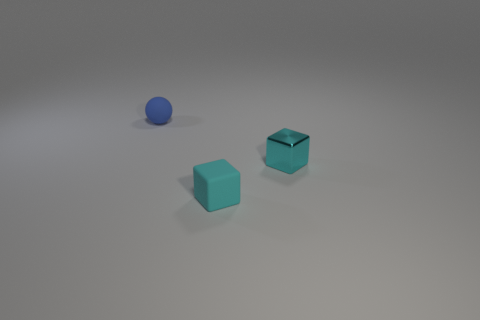What is the color of the sphere in the image? The sphere in the image is matte blue, which contrasts with the turquoise color of the cubes. 